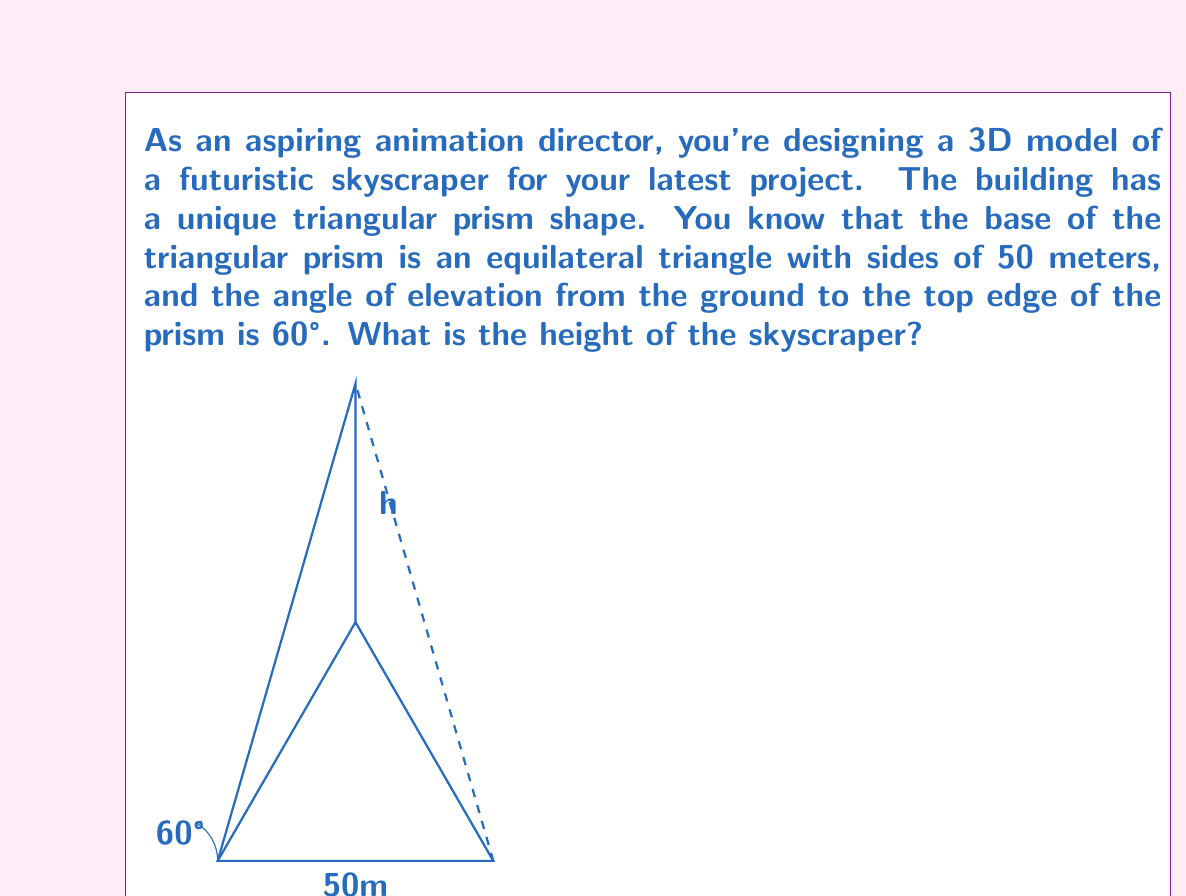Can you answer this question? Let's approach this step-by-step:

1) First, we need to find the height of the equilateral triangle base. In an equilateral triangle, the height (h) is given by:

   $$ h = \frac{\sqrt{3}}{2} \cdot side $$

   $$ h = \frac{\sqrt{3}}{2} \cdot 50 = 25\sqrt{3} \approx 43.3 \text{ meters} $$

2) Now, we can consider the right triangle formed by half of the base triangle and the height of the prism. Let's call the height of the prism H.

3) In this right triangle:
   - The base is half the width of the equilateral triangle: $25$ meters
   - The height is H minus the height of the base triangle: $H - 25\sqrt{3}$
   - The angle at the base is 60°

4) We can use the tangent ratio:

   $$ \tan 60° = \frac{H - 25\sqrt{3}}{25} $$

5) We know that $\tan 60° = \sqrt{3}$, so:

   $$ \sqrt{3} = \frac{H - 25\sqrt{3}}{25} $$

6) Solving for H:

   $$ 25\sqrt{3} = H - 25\sqrt{3} $$
   $$ 50\sqrt{3} = H $$

7) Converting to a decimal:

   $$ H \approx 86.6 \text{ meters} $$
Answer: $50\sqrt{3} \approx 86.6$ meters 